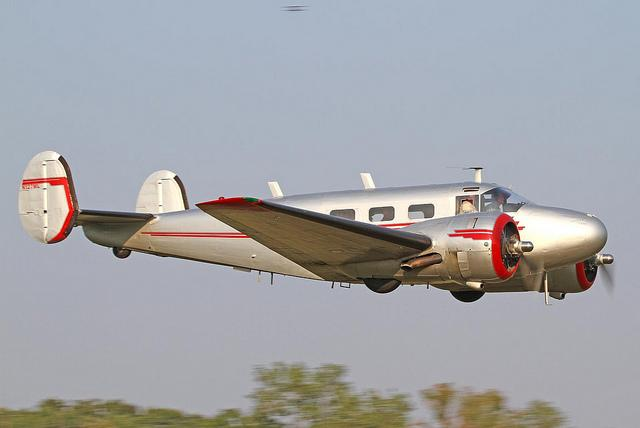What is seen in the sky? Please explain your reasoning. airplane. This is obvious given the shape of the aircraft. 